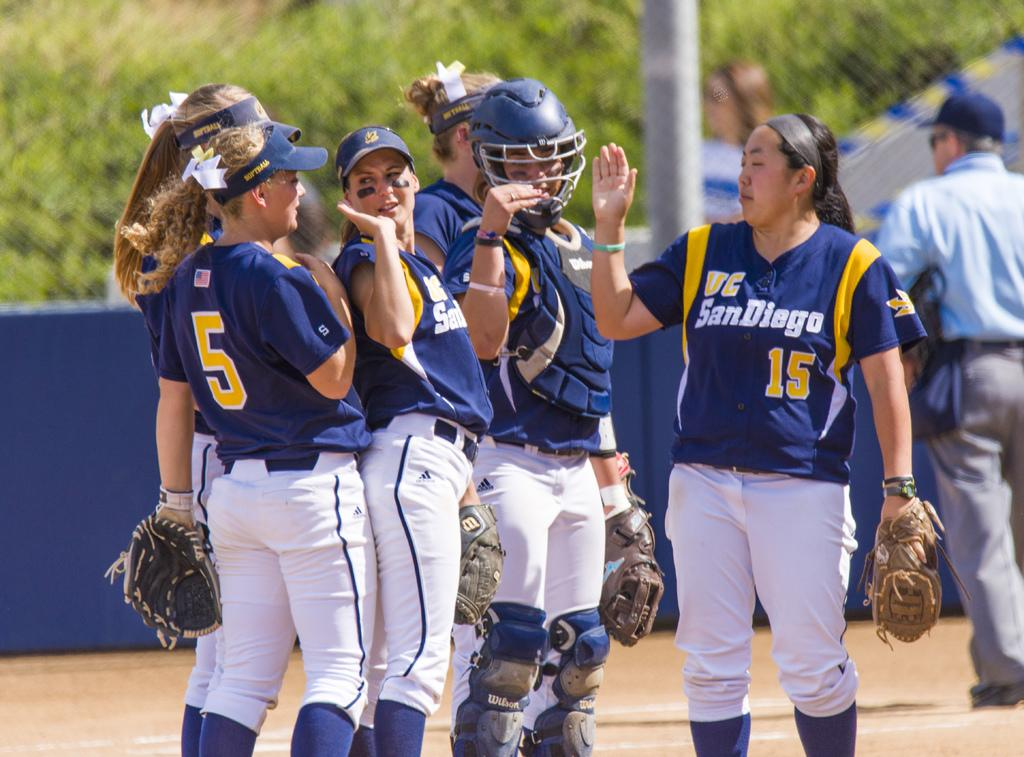Provide a one-sentence caption for the provided image. Baseball players in blue and gold uniforms with wording  VC San Diego giving eachother high fives. 